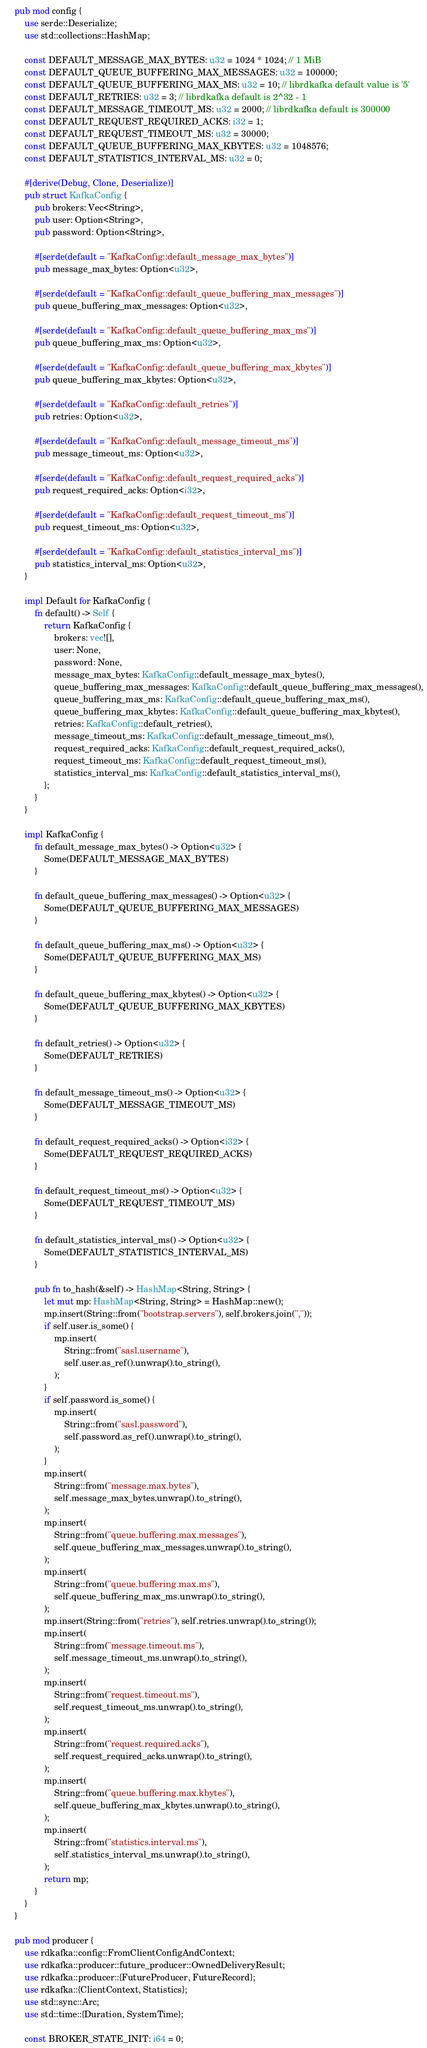Convert code to text. <code><loc_0><loc_0><loc_500><loc_500><_Rust_>pub mod config {
    use serde::Deserialize;
    use std::collections::HashMap;

    const DEFAULT_MESSAGE_MAX_BYTES: u32 = 1024 * 1024; // 1 MiB
    const DEFAULT_QUEUE_BUFFERING_MAX_MESSAGES: u32 = 100000;
    const DEFAULT_QUEUE_BUFFERING_MAX_MS: u32 = 10; // librdkafka default value is '5'
    const DEFAULT_RETRIES: u32 = 3; // librdkafka default is 2^32 - 1
    const DEFAULT_MESSAGE_TIMEOUT_MS: u32 = 2000; // librdkafka default is 300000
    const DEFAULT_REQUEST_REQUIRED_ACKS: i32 = 1;
    const DEFAULT_REQUEST_TIMEOUT_MS: u32 = 30000;
    const DEFAULT_QUEUE_BUFFERING_MAX_KBYTES: u32 = 1048576;
    const DEFAULT_STATISTICS_INTERVAL_MS: u32 = 0;

    #[derive(Debug, Clone, Deserialize)]
    pub struct KafkaConfig {
        pub brokers: Vec<String>,
        pub user: Option<String>,
        pub password: Option<String>,

        #[serde(default = "KafkaConfig::default_message_max_bytes")]
        pub message_max_bytes: Option<u32>,

        #[serde(default = "KafkaConfig::default_queue_buffering_max_messages")]
        pub queue_buffering_max_messages: Option<u32>,

        #[serde(default = "KafkaConfig::default_queue_buffering_max_ms")]
        pub queue_buffering_max_ms: Option<u32>,

        #[serde(default = "KafkaConfig::default_queue_buffering_max_kbytes")]
        pub queue_buffering_max_kbytes: Option<u32>,

        #[serde(default = "KafkaConfig::default_retries")]
        pub retries: Option<u32>,

        #[serde(default = "KafkaConfig::default_message_timeout_ms")]
        pub message_timeout_ms: Option<u32>,

        #[serde(default = "KafkaConfig::default_request_required_acks")]
        pub request_required_acks: Option<i32>,

        #[serde(default = "KafkaConfig::default_request_timeout_ms")]
        pub request_timeout_ms: Option<u32>,

        #[serde(default = "KafkaConfig::default_statistics_interval_ms")]
        pub statistics_interval_ms: Option<u32>,
    }

    impl Default for KafkaConfig {
        fn default() -> Self {
            return KafkaConfig {
                brokers: vec![],
                user: None,
                password: None,
                message_max_bytes: KafkaConfig::default_message_max_bytes(),
                queue_buffering_max_messages: KafkaConfig::default_queue_buffering_max_messages(),
                queue_buffering_max_ms: KafkaConfig::default_queue_buffering_max_ms(),
                queue_buffering_max_kbytes: KafkaConfig::default_queue_buffering_max_kbytes(),
                retries: KafkaConfig::default_retries(),
                message_timeout_ms: KafkaConfig::default_message_timeout_ms(),
                request_required_acks: KafkaConfig::default_request_required_acks(),
                request_timeout_ms: KafkaConfig::default_request_timeout_ms(),
                statistics_interval_ms: KafkaConfig::default_statistics_interval_ms(),
            };
        }
    }

    impl KafkaConfig {
        fn default_message_max_bytes() -> Option<u32> {
            Some(DEFAULT_MESSAGE_MAX_BYTES)
        }

        fn default_queue_buffering_max_messages() -> Option<u32> {
            Some(DEFAULT_QUEUE_BUFFERING_MAX_MESSAGES)
        }

        fn default_queue_buffering_max_ms() -> Option<u32> {
            Some(DEFAULT_QUEUE_BUFFERING_MAX_MS)
        }

        fn default_queue_buffering_max_kbytes() -> Option<u32> {
            Some(DEFAULT_QUEUE_BUFFERING_MAX_KBYTES)
        }

        fn default_retries() -> Option<u32> {
            Some(DEFAULT_RETRIES)
        }

        fn default_message_timeout_ms() -> Option<u32> {
            Some(DEFAULT_MESSAGE_TIMEOUT_MS)
        }

        fn default_request_required_acks() -> Option<i32> {
            Some(DEFAULT_REQUEST_REQUIRED_ACKS)
        }

        fn default_request_timeout_ms() -> Option<u32> {
            Some(DEFAULT_REQUEST_TIMEOUT_MS)
        }

        fn default_statistics_interval_ms() -> Option<u32> {
            Some(DEFAULT_STATISTICS_INTERVAL_MS)
        }

        pub fn to_hash(&self) -> HashMap<String, String> {
            let mut mp: HashMap<String, String> = HashMap::new();
            mp.insert(String::from("bootstrap.servers"), self.brokers.join(","));
            if self.user.is_some() {
                mp.insert(
                    String::from("sasl.username"),
                    self.user.as_ref().unwrap().to_string(),
                );
            }
            if self.password.is_some() {
                mp.insert(
                    String::from("sasl.password"),
                    self.password.as_ref().unwrap().to_string(),
                );
            }
            mp.insert(
                String::from("message.max.bytes"),
                self.message_max_bytes.unwrap().to_string(),
            );
            mp.insert(
                String::from("queue.buffering.max.messages"),
                self.queue_buffering_max_messages.unwrap().to_string(),
            );
            mp.insert(
                String::from("queue.buffering.max.ms"),
                self.queue_buffering_max_ms.unwrap().to_string(),
            );
            mp.insert(String::from("retries"), self.retries.unwrap().to_string());
            mp.insert(
                String::from("message.timeout.ms"),
                self.message_timeout_ms.unwrap().to_string(),
            );
            mp.insert(
                String::from("request.timeout.ms"),
                self.request_timeout_ms.unwrap().to_string(),
            );
            mp.insert(
                String::from("request.required.acks"),
                self.request_required_acks.unwrap().to_string(),
            );
            mp.insert(
                String::from("queue.buffering.max.kbytes"),
                self.queue_buffering_max_kbytes.unwrap().to_string(),
            );
            mp.insert(
                String::from("statistics.interval.ms"),
                self.statistics_interval_ms.unwrap().to_string(),
            );
            return mp;
        }
    }
}

pub mod producer {
    use rdkafka::config::FromClientConfigAndContext;
    use rdkafka::producer::future_producer::OwnedDeliveryResult;
    use rdkafka::producer::{FutureProducer, FutureRecord};
    use rdkafka::{ClientContext, Statistics};
    use std::sync::Arc;
    use std::time::{Duration, SystemTime};

    const BROKER_STATE_INIT: i64 = 0;</code> 